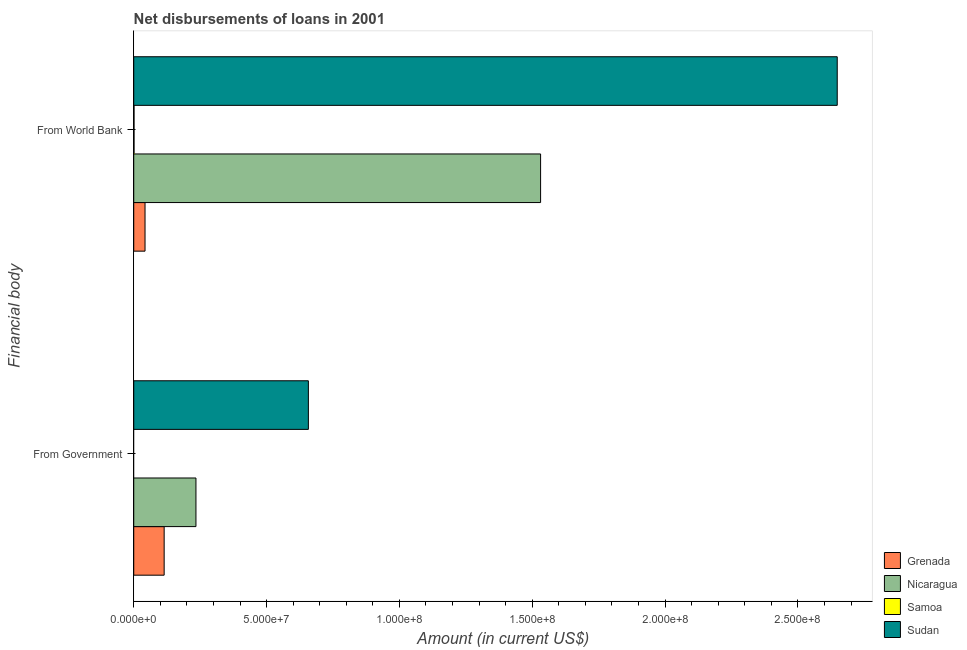Are the number of bars on each tick of the Y-axis equal?
Make the answer very short. No. What is the label of the 2nd group of bars from the top?
Offer a very short reply. From Government. What is the net disbursements of loan from government in Sudan?
Your answer should be compact. 6.57e+07. Across all countries, what is the maximum net disbursements of loan from world bank?
Offer a very short reply. 2.65e+08. Across all countries, what is the minimum net disbursements of loan from world bank?
Your response must be concise. 1.08e+05. In which country was the net disbursements of loan from world bank maximum?
Offer a very short reply. Sudan. What is the total net disbursements of loan from government in the graph?
Offer a terse response. 1.01e+08. What is the difference between the net disbursements of loan from world bank in Samoa and that in Nicaragua?
Ensure brevity in your answer.  -1.53e+08. What is the difference between the net disbursements of loan from world bank in Grenada and the net disbursements of loan from government in Sudan?
Your response must be concise. -6.15e+07. What is the average net disbursements of loan from government per country?
Offer a very short reply. 2.51e+07. What is the difference between the net disbursements of loan from government and net disbursements of loan from world bank in Nicaragua?
Your answer should be very brief. -1.30e+08. What is the ratio of the net disbursements of loan from world bank in Samoa to that in Nicaragua?
Offer a very short reply. 0. How many bars are there?
Your response must be concise. 7. What is the difference between two consecutive major ticks on the X-axis?
Your answer should be very brief. 5.00e+07. Are the values on the major ticks of X-axis written in scientific E-notation?
Offer a terse response. Yes. Does the graph contain any zero values?
Provide a succinct answer. Yes. Where does the legend appear in the graph?
Offer a very short reply. Bottom right. How many legend labels are there?
Give a very brief answer. 4. What is the title of the graph?
Make the answer very short. Net disbursements of loans in 2001. Does "Zambia" appear as one of the legend labels in the graph?
Keep it short and to the point. No. What is the label or title of the X-axis?
Your answer should be very brief. Amount (in current US$). What is the label or title of the Y-axis?
Offer a terse response. Financial body. What is the Amount (in current US$) of Grenada in From Government?
Your answer should be very brief. 1.14e+07. What is the Amount (in current US$) of Nicaragua in From Government?
Ensure brevity in your answer.  2.34e+07. What is the Amount (in current US$) in Sudan in From Government?
Offer a very short reply. 6.57e+07. What is the Amount (in current US$) in Grenada in From World Bank?
Provide a succinct answer. 4.25e+06. What is the Amount (in current US$) in Nicaragua in From World Bank?
Your answer should be very brief. 1.53e+08. What is the Amount (in current US$) of Samoa in From World Bank?
Make the answer very short. 1.08e+05. What is the Amount (in current US$) of Sudan in From World Bank?
Give a very brief answer. 2.65e+08. Across all Financial body, what is the maximum Amount (in current US$) in Grenada?
Offer a terse response. 1.14e+07. Across all Financial body, what is the maximum Amount (in current US$) of Nicaragua?
Offer a very short reply. 1.53e+08. Across all Financial body, what is the maximum Amount (in current US$) of Samoa?
Your answer should be very brief. 1.08e+05. Across all Financial body, what is the maximum Amount (in current US$) in Sudan?
Make the answer very short. 2.65e+08. Across all Financial body, what is the minimum Amount (in current US$) of Grenada?
Make the answer very short. 4.25e+06. Across all Financial body, what is the minimum Amount (in current US$) of Nicaragua?
Provide a succinct answer. 2.34e+07. Across all Financial body, what is the minimum Amount (in current US$) of Samoa?
Your response must be concise. 0. Across all Financial body, what is the minimum Amount (in current US$) of Sudan?
Provide a short and direct response. 6.57e+07. What is the total Amount (in current US$) in Grenada in the graph?
Make the answer very short. 1.57e+07. What is the total Amount (in current US$) in Nicaragua in the graph?
Provide a succinct answer. 1.77e+08. What is the total Amount (in current US$) of Samoa in the graph?
Offer a very short reply. 1.08e+05. What is the total Amount (in current US$) of Sudan in the graph?
Keep it short and to the point. 3.31e+08. What is the difference between the Amount (in current US$) of Grenada in From Government and that in From World Bank?
Give a very brief answer. 7.20e+06. What is the difference between the Amount (in current US$) of Nicaragua in From Government and that in From World Bank?
Provide a short and direct response. -1.30e+08. What is the difference between the Amount (in current US$) in Sudan in From Government and that in From World Bank?
Provide a short and direct response. -1.99e+08. What is the difference between the Amount (in current US$) of Grenada in From Government and the Amount (in current US$) of Nicaragua in From World Bank?
Your answer should be very brief. -1.42e+08. What is the difference between the Amount (in current US$) in Grenada in From Government and the Amount (in current US$) in Samoa in From World Bank?
Your answer should be compact. 1.13e+07. What is the difference between the Amount (in current US$) in Grenada in From Government and the Amount (in current US$) in Sudan in From World Bank?
Give a very brief answer. -2.53e+08. What is the difference between the Amount (in current US$) in Nicaragua in From Government and the Amount (in current US$) in Samoa in From World Bank?
Provide a succinct answer. 2.33e+07. What is the difference between the Amount (in current US$) of Nicaragua in From Government and the Amount (in current US$) of Sudan in From World Bank?
Keep it short and to the point. -2.41e+08. What is the average Amount (in current US$) in Grenada per Financial body?
Provide a succinct answer. 7.85e+06. What is the average Amount (in current US$) of Nicaragua per Financial body?
Keep it short and to the point. 8.83e+07. What is the average Amount (in current US$) in Samoa per Financial body?
Offer a very short reply. 5.40e+04. What is the average Amount (in current US$) in Sudan per Financial body?
Provide a succinct answer. 1.65e+08. What is the difference between the Amount (in current US$) in Grenada and Amount (in current US$) in Nicaragua in From Government?
Your answer should be very brief. -1.20e+07. What is the difference between the Amount (in current US$) of Grenada and Amount (in current US$) of Sudan in From Government?
Your answer should be very brief. -5.43e+07. What is the difference between the Amount (in current US$) of Nicaragua and Amount (in current US$) of Sudan in From Government?
Your answer should be compact. -4.23e+07. What is the difference between the Amount (in current US$) in Grenada and Amount (in current US$) in Nicaragua in From World Bank?
Your answer should be very brief. -1.49e+08. What is the difference between the Amount (in current US$) of Grenada and Amount (in current US$) of Samoa in From World Bank?
Provide a short and direct response. 4.14e+06. What is the difference between the Amount (in current US$) of Grenada and Amount (in current US$) of Sudan in From World Bank?
Keep it short and to the point. -2.61e+08. What is the difference between the Amount (in current US$) in Nicaragua and Amount (in current US$) in Samoa in From World Bank?
Offer a very short reply. 1.53e+08. What is the difference between the Amount (in current US$) of Nicaragua and Amount (in current US$) of Sudan in From World Bank?
Ensure brevity in your answer.  -1.12e+08. What is the difference between the Amount (in current US$) in Samoa and Amount (in current US$) in Sudan in From World Bank?
Ensure brevity in your answer.  -2.65e+08. What is the ratio of the Amount (in current US$) of Grenada in From Government to that in From World Bank?
Provide a short and direct response. 2.69. What is the ratio of the Amount (in current US$) in Nicaragua in From Government to that in From World Bank?
Provide a succinct answer. 0.15. What is the ratio of the Amount (in current US$) in Sudan in From Government to that in From World Bank?
Ensure brevity in your answer.  0.25. What is the difference between the highest and the second highest Amount (in current US$) of Grenada?
Your answer should be very brief. 7.20e+06. What is the difference between the highest and the second highest Amount (in current US$) in Nicaragua?
Give a very brief answer. 1.30e+08. What is the difference between the highest and the second highest Amount (in current US$) in Sudan?
Make the answer very short. 1.99e+08. What is the difference between the highest and the lowest Amount (in current US$) of Grenada?
Ensure brevity in your answer.  7.20e+06. What is the difference between the highest and the lowest Amount (in current US$) of Nicaragua?
Ensure brevity in your answer.  1.30e+08. What is the difference between the highest and the lowest Amount (in current US$) of Samoa?
Offer a terse response. 1.08e+05. What is the difference between the highest and the lowest Amount (in current US$) of Sudan?
Make the answer very short. 1.99e+08. 